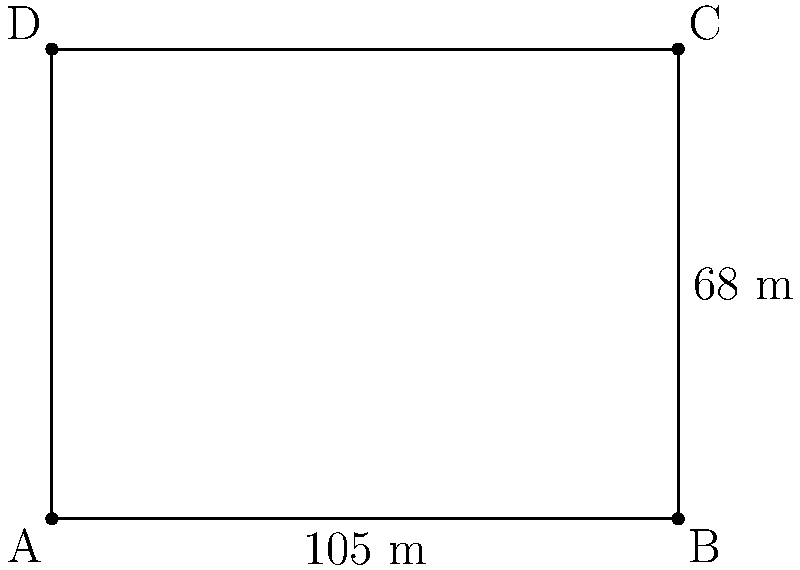Your favorite team's stadium has a rectangular football pitch with dimensions 105 meters long and 68 meters wide. What is the total area of the pitch in square meters? To find the area of a rectangular football pitch, we need to multiply its length by its width. Let's break it down step-by-step:

1. Identify the given dimensions:
   - Length = 105 meters
   - Width = 68 meters

2. Use the formula for the area of a rectangle:
   Area = Length × Width

3. Substitute the values into the formula:
   Area = 105 m × 68 m

4. Perform the multiplication:
   Area = 7,140 m²

Therefore, the total area of the football pitch is 7,140 square meters.
Answer: 7,140 m² 